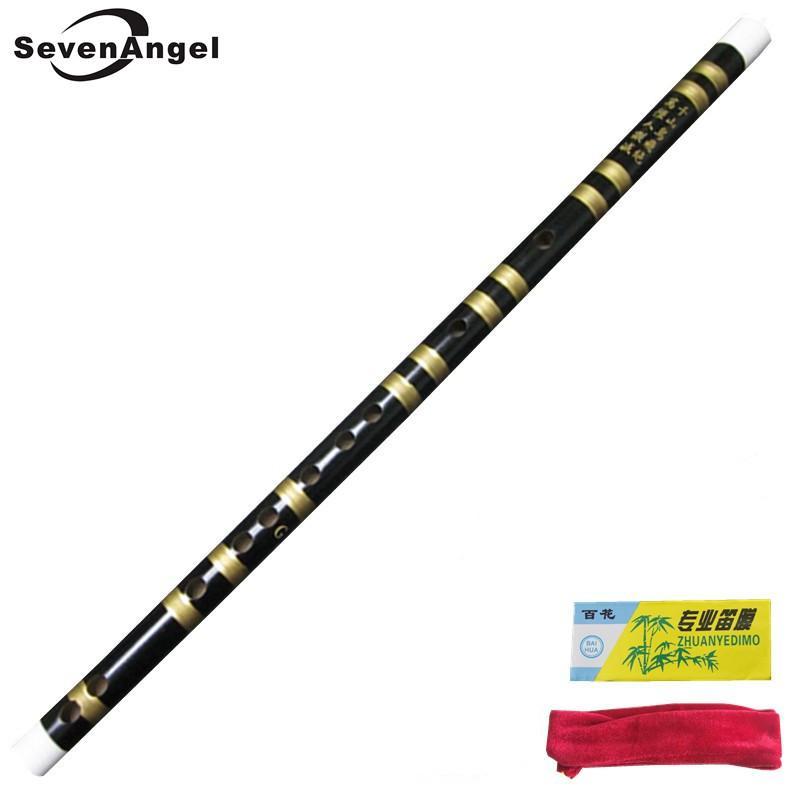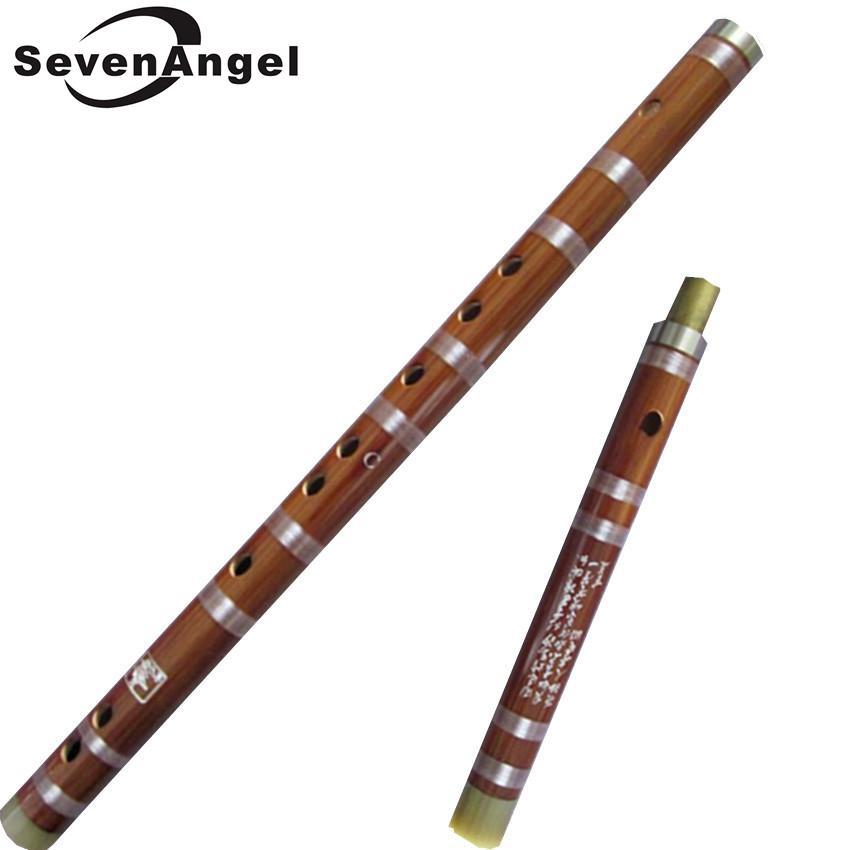The first image is the image on the left, the second image is the image on the right. Considering the images on both sides, is "One of the instruments is taken apart into two separate pieces." valid? Answer yes or no. Yes. The first image is the image on the left, the second image is the image on the right. Considering the images on both sides, is "The instrument in the image on the right is broken apart into several pieces." valid? Answer yes or no. Yes. 